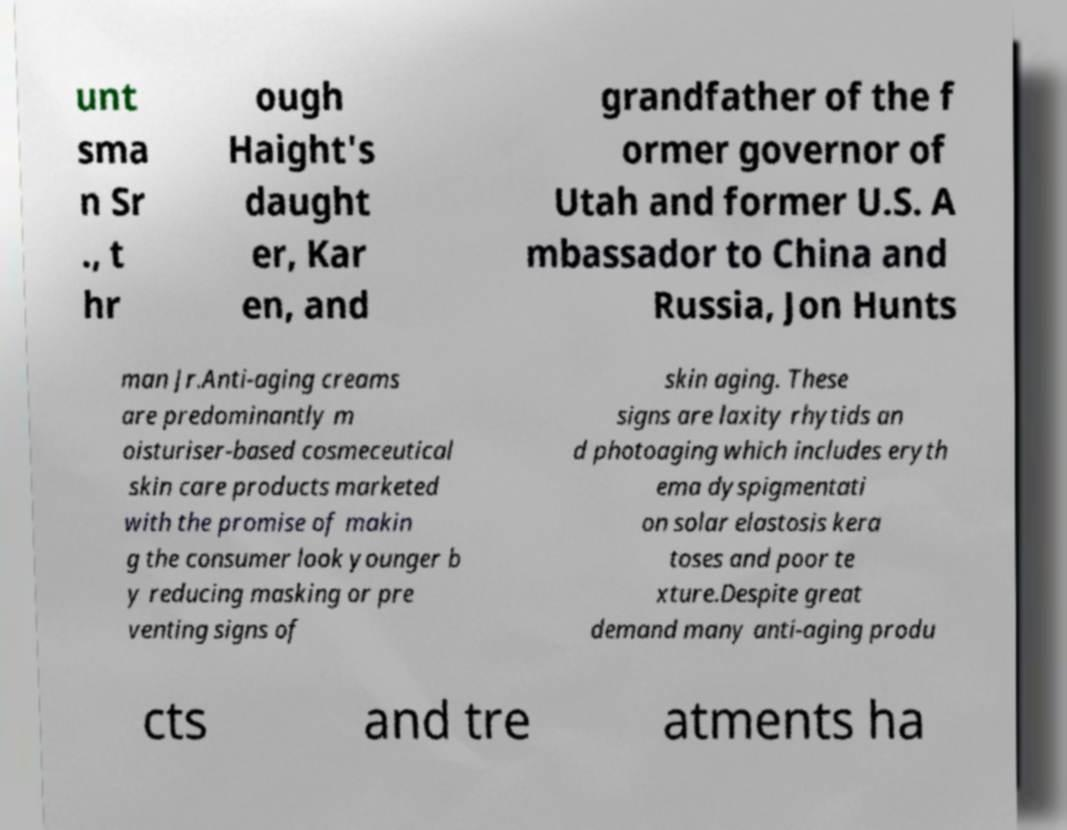Can you read and provide the text displayed in the image?This photo seems to have some interesting text. Can you extract and type it out for me? unt sma n Sr ., t hr ough Haight's daught er, Kar en, and grandfather of the f ormer governor of Utah and former U.S. A mbassador to China and Russia, Jon Hunts man Jr.Anti-aging creams are predominantly m oisturiser-based cosmeceutical skin care products marketed with the promise of makin g the consumer look younger b y reducing masking or pre venting signs of skin aging. These signs are laxity rhytids an d photoaging which includes eryth ema dyspigmentati on solar elastosis kera toses and poor te xture.Despite great demand many anti-aging produ cts and tre atments ha 